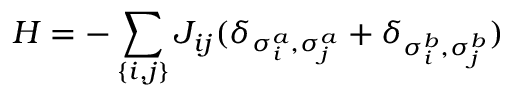Convert formula to latex. <formula><loc_0><loc_0><loc_500><loc_500>H = - \sum _ { \{ i , j \} } J _ { i j } ( \delta _ { \sigma _ { i } ^ { a } , \sigma _ { j } ^ { a } } + \delta _ { \sigma _ { i } ^ { b } , \sigma _ { j } ^ { b } } )</formula> 